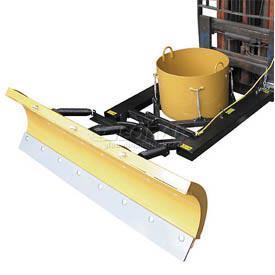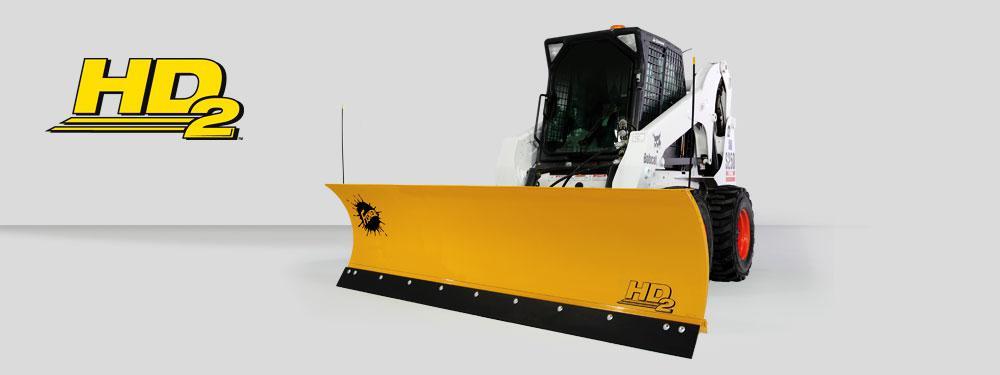The first image is the image on the left, the second image is the image on the right. Examine the images to the left and right. Is the description "Left image shows a camera-facing vehicle plowing a snow-covered ground." accurate? Answer yes or no. No. The first image is the image on the left, the second image is the image on the right. Analyze the images presented: Is the assertion "A pile of snow is being bulldozed by a vehicle." valid? Answer yes or no. No. 